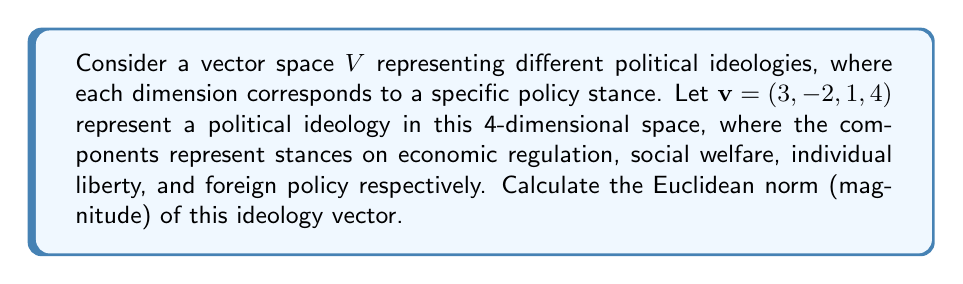Can you answer this question? To solve this problem, we need to follow these steps:

1) The Euclidean norm (also known as L2 norm) of a vector $x = (x_1, x_2, ..., x_n)$ is defined as:

   $$\|x\| = \sqrt{\sum_{i=1}^n x_i^2}$$

2) In our case, $v = (3, -2, 1, 4)$, so we need to calculate:

   $$\|v\| = \sqrt{3^2 + (-2)^2 + 1^2 + 4^2}$$

3) Let's compute each term:
   
   $3^2 = 9$
   $(-2)^2 = 4$
   $1^2 = 1$
   $4^2 = 16$

4) Sum these terms:

   $$\|v\| = \sqrt{9 + 4 + 1 + 16} = \sqrt{30}$$

5) Simplify:

   $$\|v\| = \sqrt{30} = \sqrt{2} \cdot \sqrt{15} \approx 5.477$$

This result represents the magnitude of the political ideology in the given vector space. In the context of Rawls' political theory, this norm could be interpreted as a measure of how far this ideology deviates from a neutral or centrist position (represented by the zero vector) across the considered policy dimensions.
Answer: $\|v\| = \sqrt{30}$ or approximately 5.477 